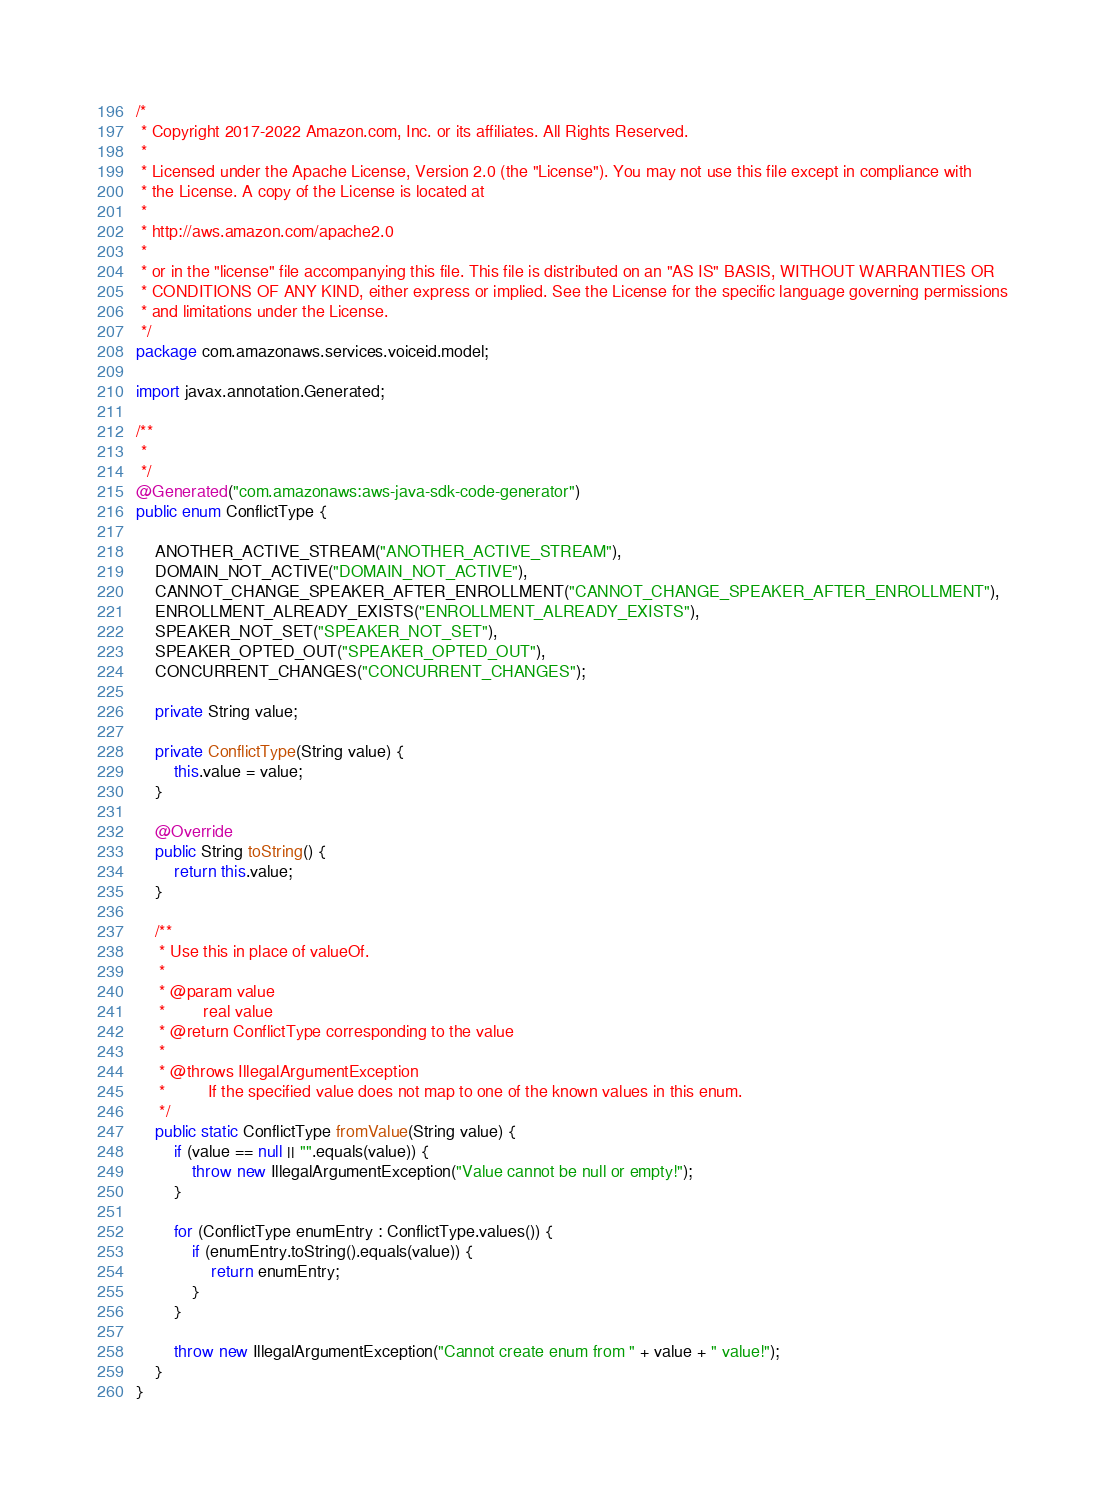<code> <loc_0><loc_0><loc_500><loc_500><_Java_>/*
 * Copyright 2017-2022 Amazon.com, Inc. or its affiliates. All Rights Reserved.
 * 
 * Licensed under the Apache License, Version 2.0 (the "License"). You may not use this file except in compliance with
 * the License. A copy of the License is located at
 * 
 * http://aws.amazon.com/apache2.0
 * 
 * or in the "license" file accompanying this file. This file is distributed on an "AS IS" BASIS, WITHOUT WARRANTIES OR
 * CONDITIONS OF ANY KIND, either express or implied. See the License for the specific language governing permissions
 * and limitations under the License.
 */
package com.amazonaws.services.voiceid.model;

import javax.annotation.Generated;

/**
 * 
 */
@Generated("com.amazonaws:aws-java-sdk-code-generator")
public enum ConflictType {

    ANOTHER_ACTIVE_STREAM("ANOTHER_ACTIVE_STREAM"),
    DOMAIN_NOT_ACTIVE("DOMAIN_NOT_ACTIVE"),
    CANNOT_CHANGE_SPEAKER_AFTER_ENROLLMENT("CANNOT_CHANGE_SPEAKER_AFTER_ENROLLMENT"),
    ENROLLMENT_ALREADY_EXISTS("ENROLLMENT_ALREADY_EXISTS"),
    SPEAKER_NOT_SET("SPEAKER_NOT_SET"),
    SPEAKER_OPTED_OUT("SPEAKER_OPTED_OUT"),
    CONCURRENT_CHANGES("CONCURRENT_CHANGES");

    private String value;

    private ConflictType(String value) {
        this.value = value;
    }

    @Override
    public String toString() {
        return this.value;
    }

    /**
     * Use this in place of valueOf.
     *
     * @param value
     *        real value
     * @return ConflictType corresponding to the value
     *
     * @throws IllegalArgumentException
     *         If the specified value does not map to one of the known values in this enum.
     */
    public static ConflictType fromValue(String value) {
        if (value == null || "".equals(value)) {
            throw new IllegalArgumentException("Value cannot be null or empty!");
        }

        for (ConflictType enumEntry : ConflictType.values()) {
            if (enumEntry.toString().equals(value)) {
                return enumEntry;
            }
        }

        throw new IllegalArgumentException("Cannot create enum from " + value + " value!");
    }
}
</code> 